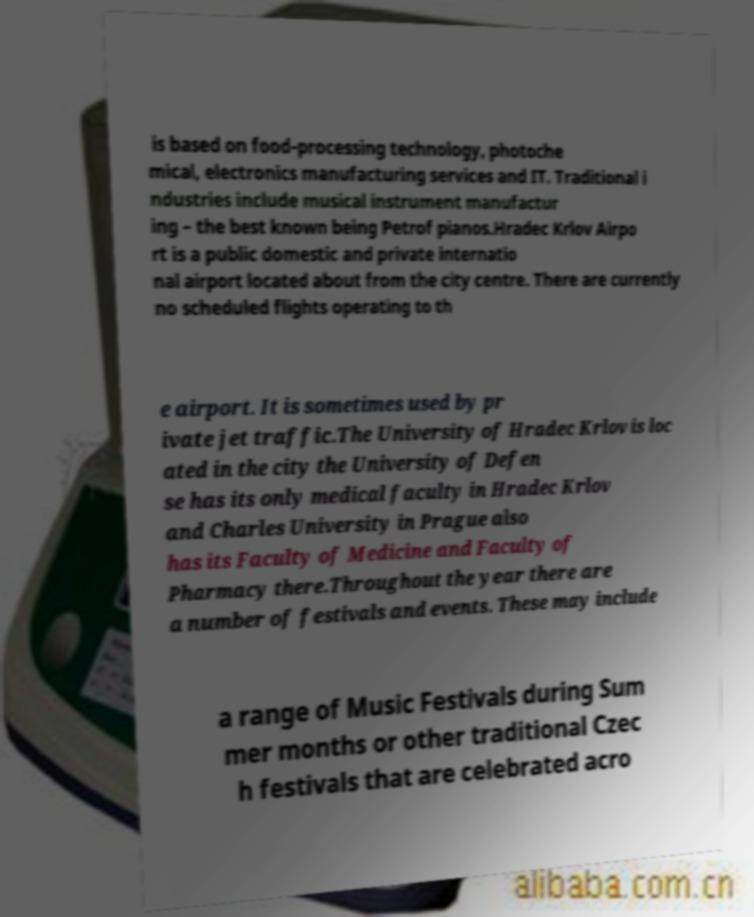Please read and relay the text visible in this image. What does it say? is based on food-processing technology, photoche mical, electronics manufacturing services and IT. Traditional i ndustries include musical instrument manufactur ing – the best known being Petrof pianos.Hradec Krlov Airpo rt is a public domestic and private internatio nal airport located about from the city centre. There are currently no scheduled flights operating to th e airport. It is sometimes used by pr ivate jet traffic.The University of Hradec Krlov is loc ated in the city the University of Defen se has its only medical faculty in Hradec Krlov and Charles University in Prague also has its Faculty of Medicine and Faculty of Pharmacy there.Throughout the year there are a number of festivals and events. These may include a range of Music Festivals during Sum mer months or other traditional Czec h festivals that are celebrated acro 